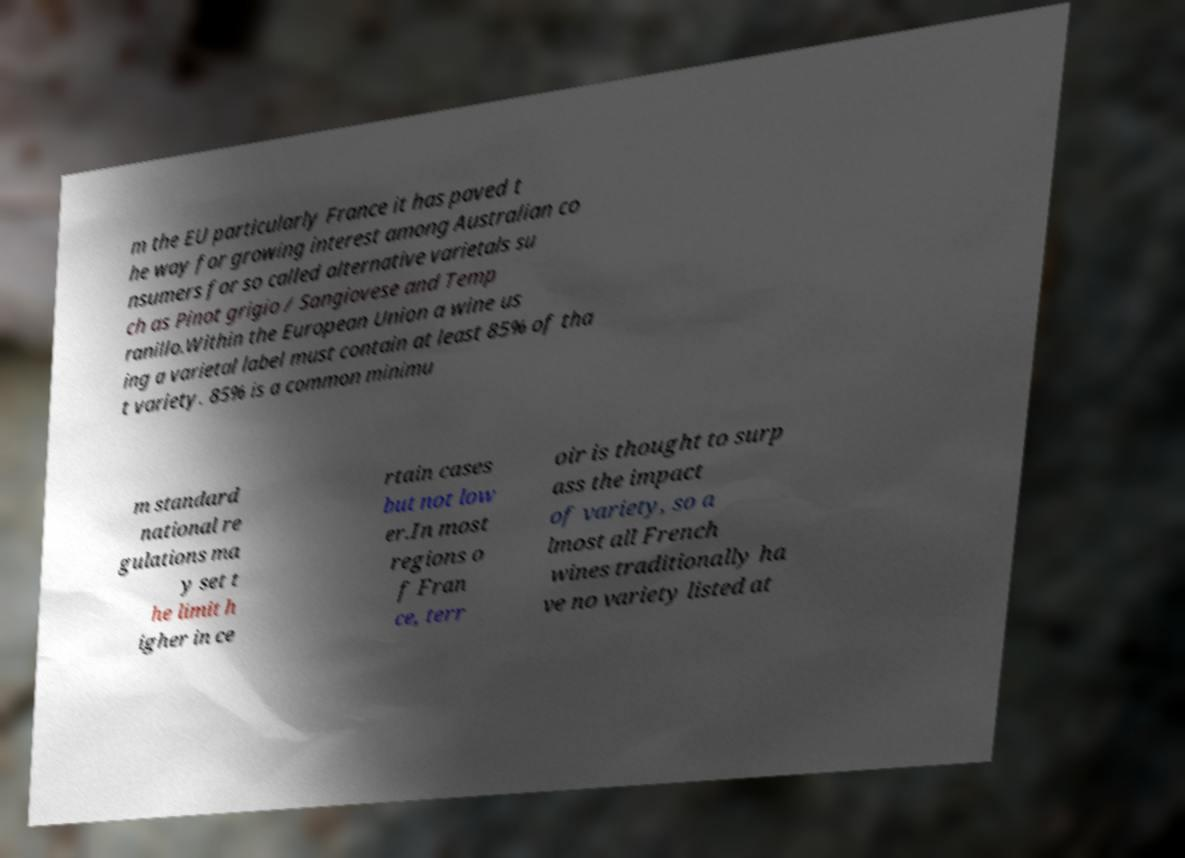There's text embedded in this image that I need extracted. Can you transcribe it verbatim? m the EU particularly France it has paved t he way for growing interest among Australian co nsumers for so called alternative varietals su ch as Pinot grigio / Sangiovese and Temp ranillo.Within the European Union a wine us ing a varietal label must contain at least 85% of tha t variety. 85% is a common minimu m standard national re gulations ma y set t he limit h igher in ce rtain cases but not low er.In most regions o f Fran ce, terr oir is thought to surp ass the impact of variety, so a lmost all French wines traditionally ha ve no variety listed at 